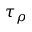Convert formula to latex. <formula><loc_0><loc_0><loc_500><loc_500>\tau _ { \rho }</formula> 